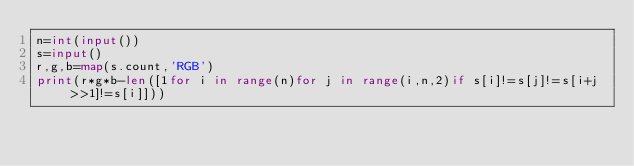Convert code to text. <code><loc_0><loc_0><loc_500><loc_500><_Python_>n=int(input())
s=input()
r,g,b=map(s.count,'RGB')
print(r*g*b-len([1for i in range(n)for j in range(i,n,2)if s[i]!=s[j]!=s[i+j>>1]!=s[i]]))</code> 